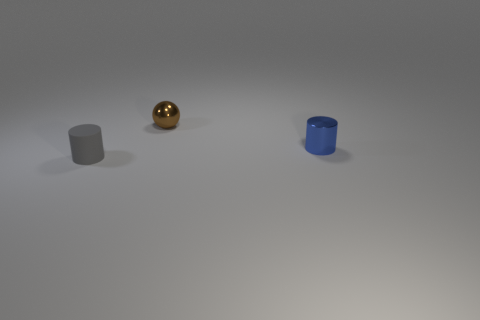What number of blue metal objects have the same size as the gray matte cylinder?
Keep it short and to the point. 1. Does the cylinder that is right of the small gray rubber object have the same material as the tiny cylinder that is in front of the small blue cylinder?
Offer a terse response. No. What material is the tiny cylinder right of the small object on the left side of the brown metal ball made of?
Provide a succinct answer. Metal. There is a cylinder right of the tiny gray cylinder; what is it made of?
Your answer should be very brief. Metal. What number of other tiny objects have the same shape as the matte object?
Provide a succinct answer. 1. Does the matte cylinder have the same color as the small sphere?
Provide a succinct answer. No. There is a tiny cylinder that is in front of the cylinder that is right of the small object in front of the blue cylinder; what is it made of?
Your response must be concise. Rubber. There is a rubber cylinder; are there any things in front of it?
Your answer should be compact. No. There is a gray rubber object that is the same size as the blue object; what is its shape?
Your answer should be very brief. Cylinder. Do the tiny blue cylinder and the gray thing have the same material?
Offer a terse response. No. 